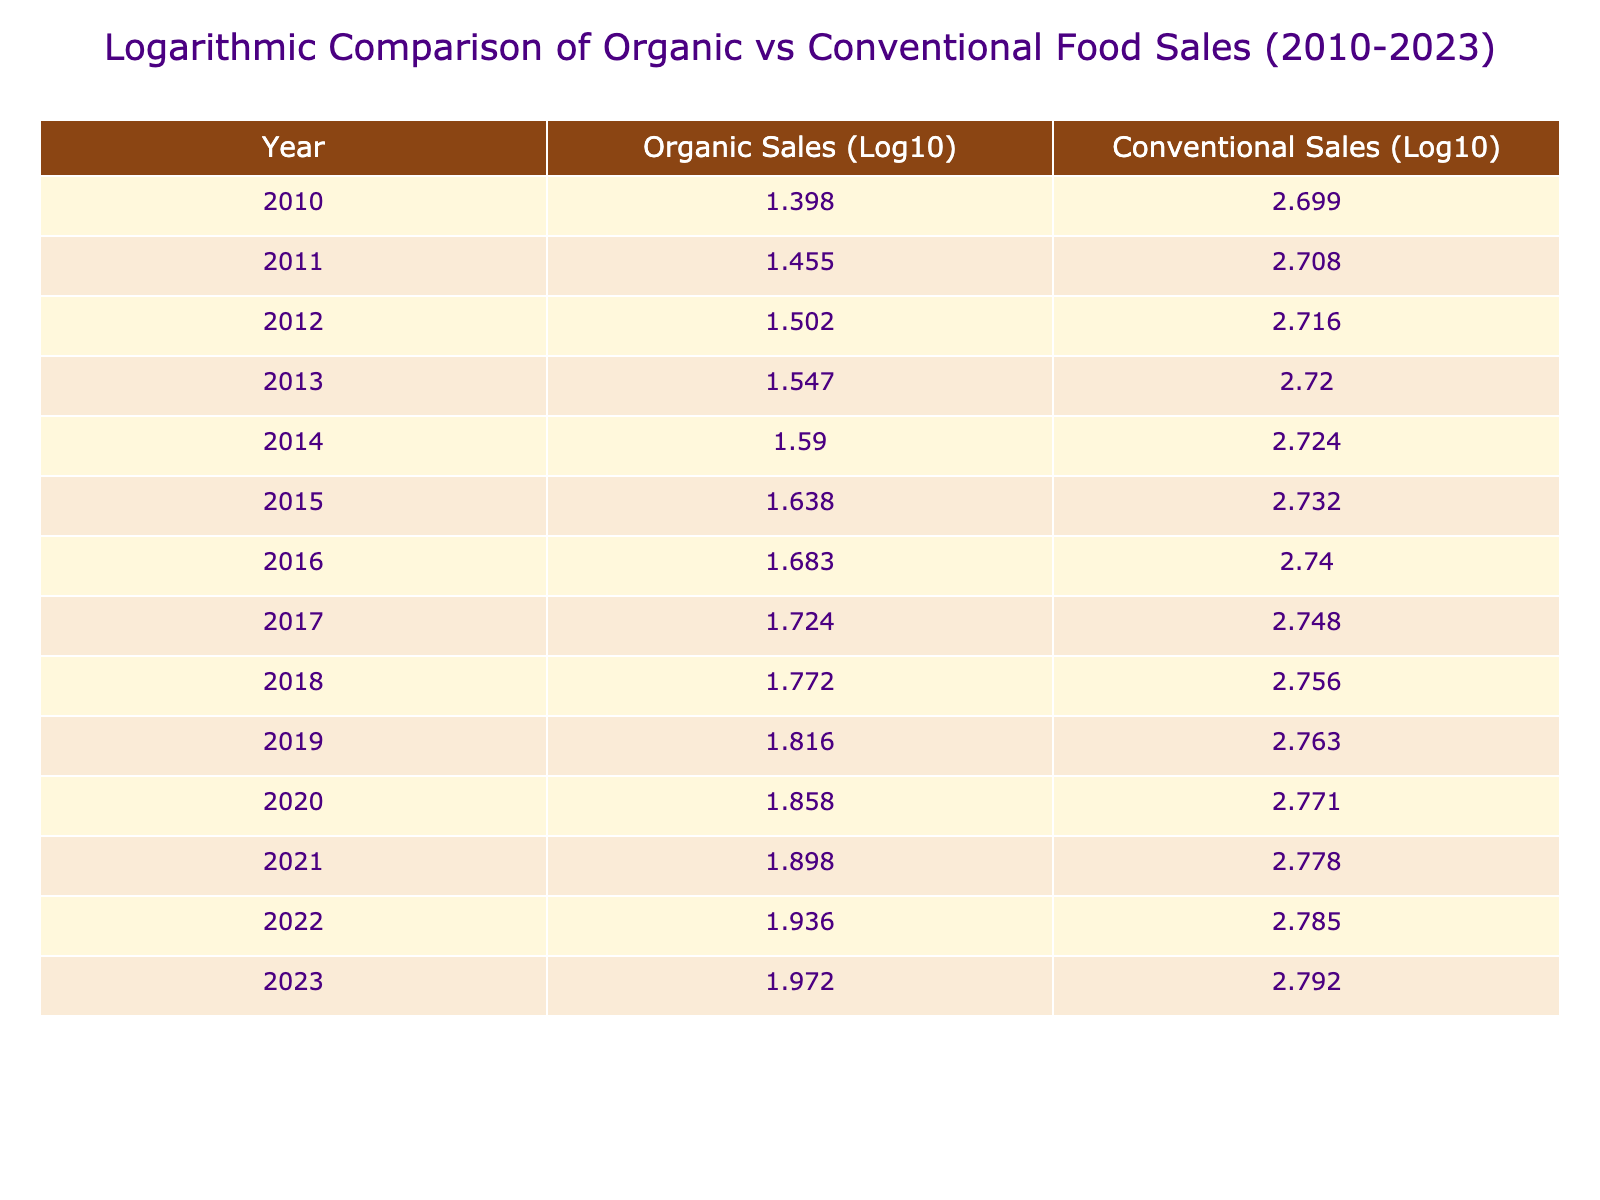What were the organic food sales in 2015? The table indicates that in the year 2015, the Organic Food Sales were 43.5 billion USD.
Answer: 43.5 billion USD In which year did organic food sales surpass 70 billion USD? According to the table, organic food sales first surpassed 70 billion USD in the year 2020, when sales reached 72.1 billion USD.
Answer: 2020 What was the difference in conventional food sales between 2010 and 2015? In 2010, conventional food sales were 500.0 billion USD and in 2015, they were 540.0 billion USD. The difference is calculated as 540.0 - 500.0 = 40.0 billion USD.
Answer: 40.0 billion USD Did organic food sales experience growth every year from 2010 to 2023? Yes, the data shows a consistent increase in organic food sales from 2010 through 2023, indicating growth every year.
Answer: Yes What was the average organic food sales growth per year from 2010 to 2023? To calculate the average organic sales growth per year, we sum the organic sales from 2010 (25.0 billion USD) to 2023 (93.8 billion USD), which gives us (93.8 - 25.0) = 68.8 billion USD. With 13 years of growth (from 2010 to 2023 counts as 13 years), the average growth per year is 68.8 / 13 ≈ 5.29 billion USD.
Answer: Approximately 5.29 billion USD In which year did organic food sales experience the highest percentage growth compared to the previous year? To find the highest percentage growth, we will examine the year-over-year changes: for example, from 2010 to 2011, the growth was (28.5 - 25.0) / 25.0 * 100 = 14%. Calculating for each year, we find that the highest percentage growth occurred from 2019 to 2020, when the percentage growth was (72.1 - 65.5) / 65.5 * 100 ≈ 8.97%.
Answer: 2019 to 2020 Were conventional food sales higher than organic sales in every year from 2010 to 2023? Yes, the table shows that conventional food sales were consistently higher than organic food sales in every single year from 2010 to 2023.
Answer: Yes What were the logarithmic values for organic sales in 2023? The table indicates that the logarithmic value of organic food sales in 2023 is approximately 1.472 when rounded to three decimal places.
Answer: 1.472 